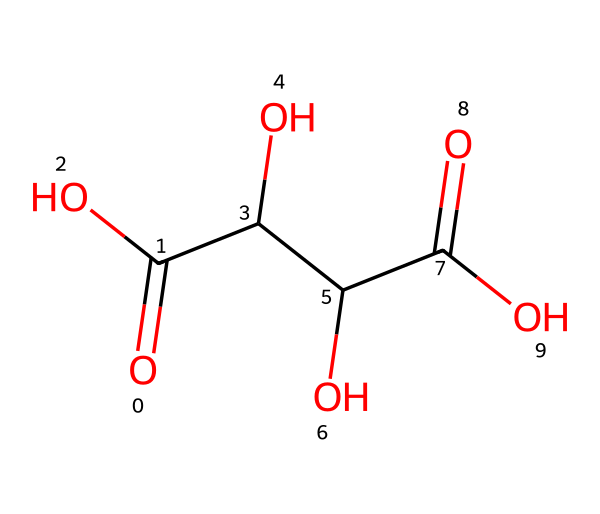What is the molecular formula of tartaric acid? To determine the molecular formula from the SMILES representation, we can identify the number of each type of atom present. The SMILES includes carbon (C), hydrogen (H), and oxygen (O) atoms. Counting gives us 4 carbon atoms, 6 hydrogen atoms, and 5 oxygen atoms, leading to the formula C4H6O5.
Answer: C4H6O5 How many hydroxyl groups are present in tartaric acid? In the structure, hydroxyl groups (-OH) are indicated by the -O- and H attached to a carbon. By examining the SMILES, we see there are 2 instances of -OH groups, which correspond to the two hydroxyl functionalities in the structure.
Answer: 2 What type of acid is tartaric acid classified as? Tartaric acid is classified as a dicarboxylic acid due to the presence of two carboxyl (-COOH) functional groups in its molecular structure, as indicated by the two carbonyl oxygen atoms bonded to hydroxyl groups.
Answer: dicarboxylic acid How many carbon atoms are in tartaric acid? The number of carbon atoms can be easily counted from the SMILES notation. After analyzing the structure represented by the SMILES, we find that there are 4 carbon atoms in total.
Answer: 4 What is the simplest way to determine the number of bonds in tartaric acid? We can analyze the structural notation in the SMILES for crystalline bonds. Each carbon atom typically forms 4 bonds to fulfill its tetravalence. By counting the bonds formed with O and H around the carbon backbone, we can sum the total bonds. The detailed structure would generally have multiple bonds due to functional groups, but the important bonds here are 8 covalent bonds connecting the atoms overall.
Answer: 8 What type of functional groups are present in tartaric acid? Tartaric acid features carboxyl groups (-COOH) as its primary functional groups. By examining the SMILES, we can see these groups typically indicate acidity due to the presence of both carbonyl (C=O) and hydroxyl (O-H) links. Since there are two such groups, we can state that it contains multiple carboxylic acid functionalities.
Answer: carboxyl groups 